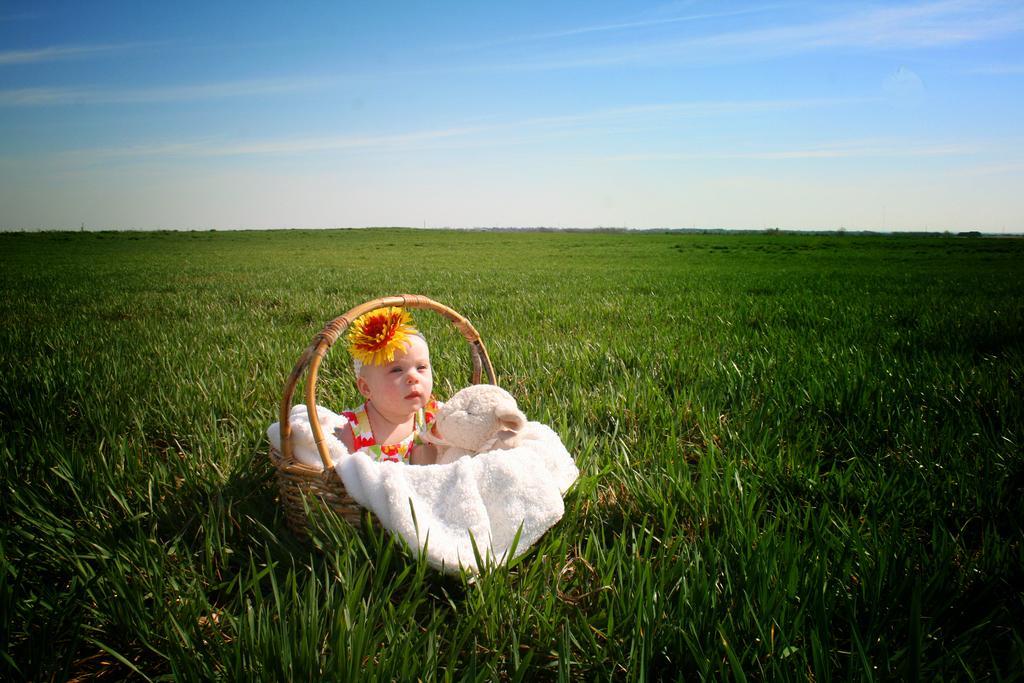Could you give a brief overview of what you see in this image? In the center of the image we can see one basket. In the basket, we can see one cloth, one doll and one kid is sitting and she is in a different costume. In the background, we can see the sky, clouds and grass. 